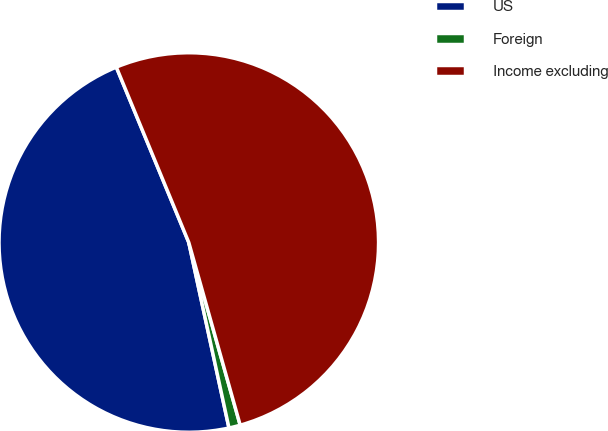Convert chart to OTSL. <chart><loc_0><loc_0><loc_500><loc_500><pie_chart><fcel>US<fcel>Foreign<fcel>Income excluding<nl><fcel>47.16%<fcel>0.97%<fcel>51.87%<nl></chart> 